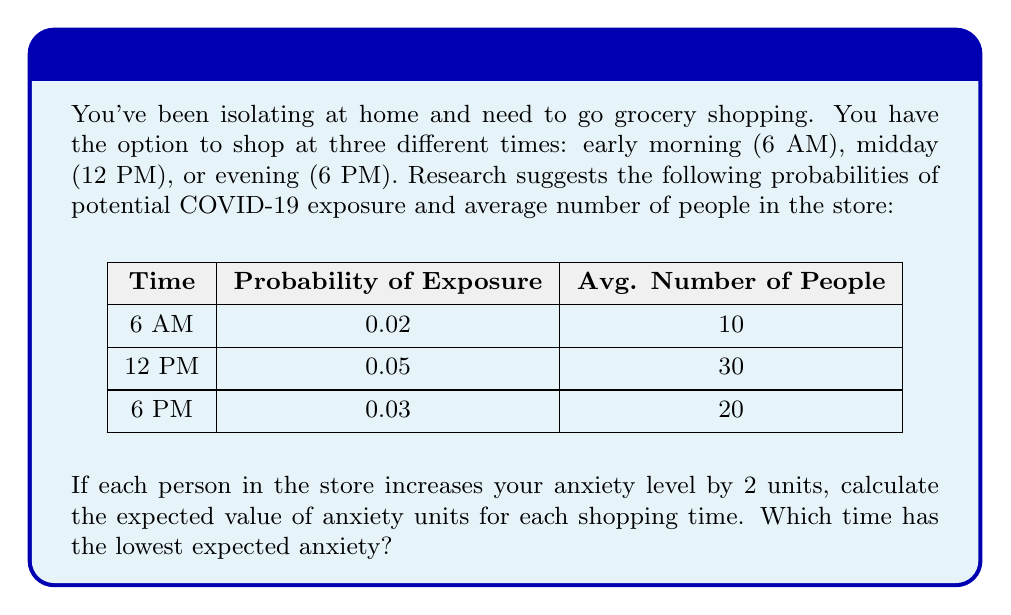Help me with this question. To solve this problem, we need to calculate the expected value of anxiety units for each shopping time. The expected value is the sum of each possible outcome multiplied by its probability.

For each time slot:
1. Calculate the anxiety units: (Average number of people) × (2 units per person)
2. Calculate the expected value: (Probability of exposure × Anxiety units) + (Probability of no exposure × 0)

Let's calculate for each time:

1. 6 AM:
   Anxiety units = 10 × 2 = 20
   Expected value = (0.02 × 20) + (0.98 × 0) = 0.4

2. 12 PM:
   Anxiety units = 30 × 2 = 60
   Expected value = (0.05 × 60) + (0.95 × 0) = 3

3. 6 PM:
   Anxiety units = 20 × 2 = 40
   Expected value = (0.03 × 40) + (0.97 × 0) = 1.2

The expected values are:
6 AM: 0.4 anxiety units
12 PM: 3 anxiety units
6 PM: 1.2 anxiety units

Therefore, the time with the lowest expected anxiety is 6 AM with 0.4 anxiety units.
Answer: 6 AM, with 0.4 expected anxiety units. 